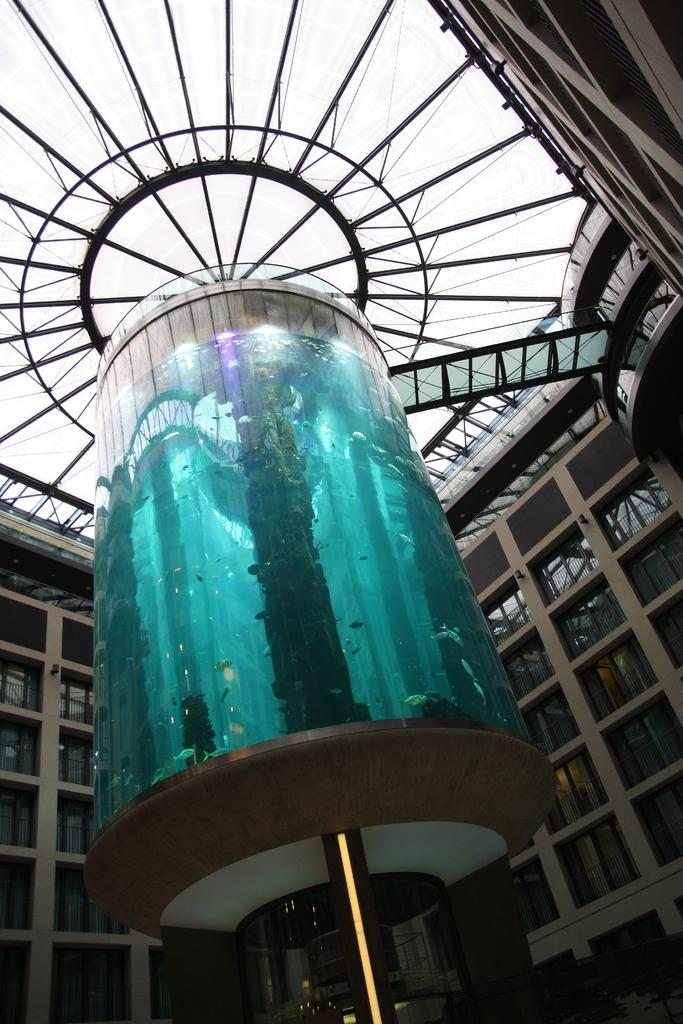What is the main object in the middle of the image? There is a glass item in the middle of the image. What can be seen in the background of the image? There is a building with glass windows in the background of the image. What is the highest part of the building visible in the image? The roof is visible in the background of the image. What is visible above the building in the image? The sky is visible in the background of the image. What type of leather material can be seen on the shirt of the person in the image? There is no person or shirt present in the image, so there is no leather material to be seen. 